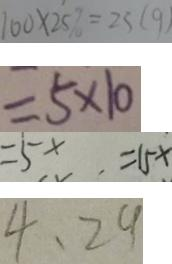Convert formula to latex. <formula><loc_0><loc_0><loc_500><loc_500>1 0 \times 2 5 \% = 2 5 ( g ) 
 = 5 \times 1 0 
 = 5 x . = 1 5 x 
 4 、 2 9</formula> 